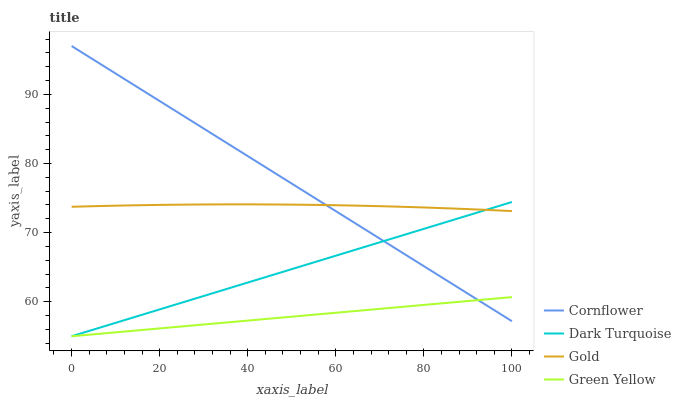Does Green Yellow have the minimum area under the curve?
Answer yes or no. Yes. Does Cornflower have the maximum area under the curve?
Answer yes or no. Yes. Does Gold have the minimum area under the curve?
Answer yes or no. No. Does Gold have the maximum area under the curve?
Answer yes or no. No. Is Green Yellow the smoothest?
Answer yes or no. Yes. Is Gold the roughest?
Answer yes or no. Yes. Is Gold the smoothest?
Answer yes or no. No. Is Green Yellow the roughest?
Answer yes or no. No. Does Green Yellow have the lowest value?
Answer yes or no. Yes. Does Gold have the lowest value?
Answer yes or no. No. Does Cornflower have the highest value?
Answer yes or no. Yes. Does Gold have the highest value?
Answer yes or no. No. Is Green Yellow less than Gold?
Answer yes or no. Yes. Is Gold greater than Green Yellow?
Answer yes or no. Yes. Does Cornflower intersect Green Yellow?
Answer yes or no. Yes. Is Cornflower less than Green Yellow?
Answer yes or no. No. Is Cornflower greater than Green Yellow?
Answer yes or no. No. Does Green Yellow intersect Gold?
Answer yes or no. No. 